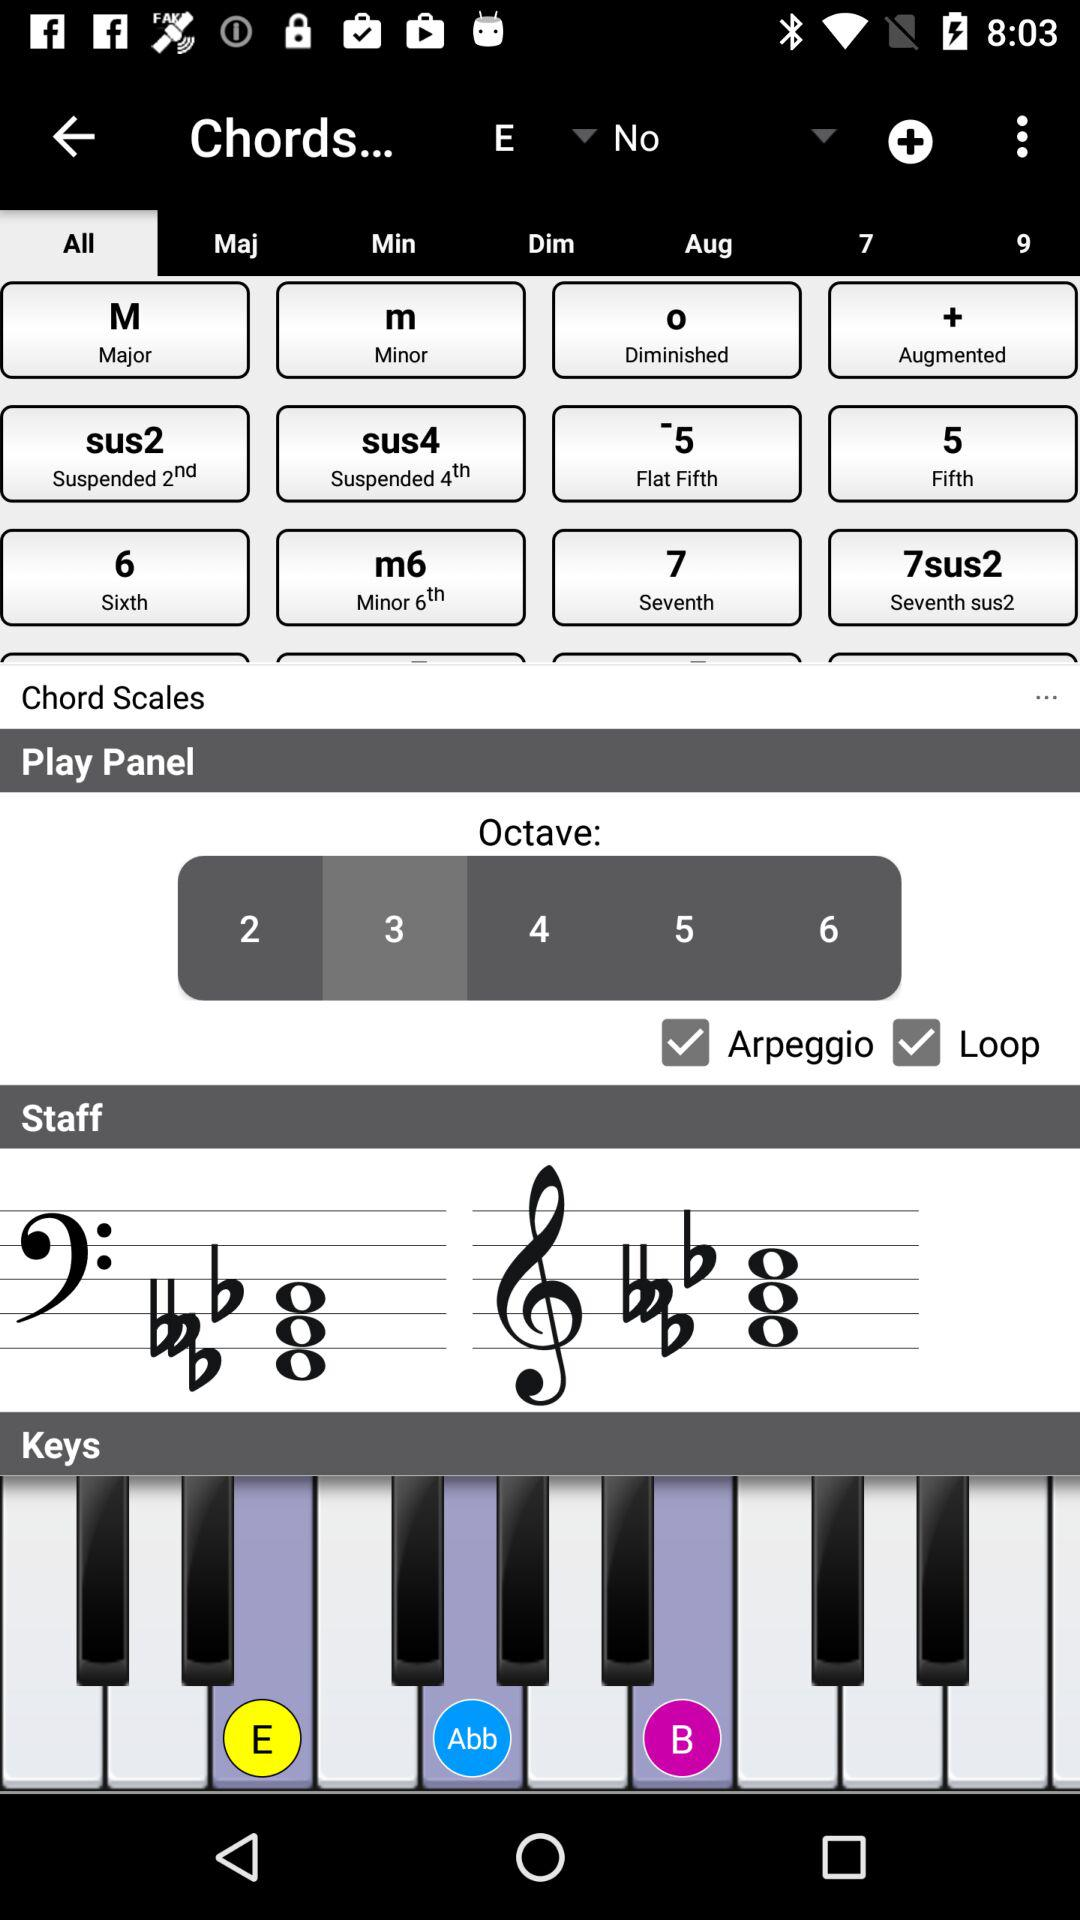What is the status of "Loop"? The status is "on". 